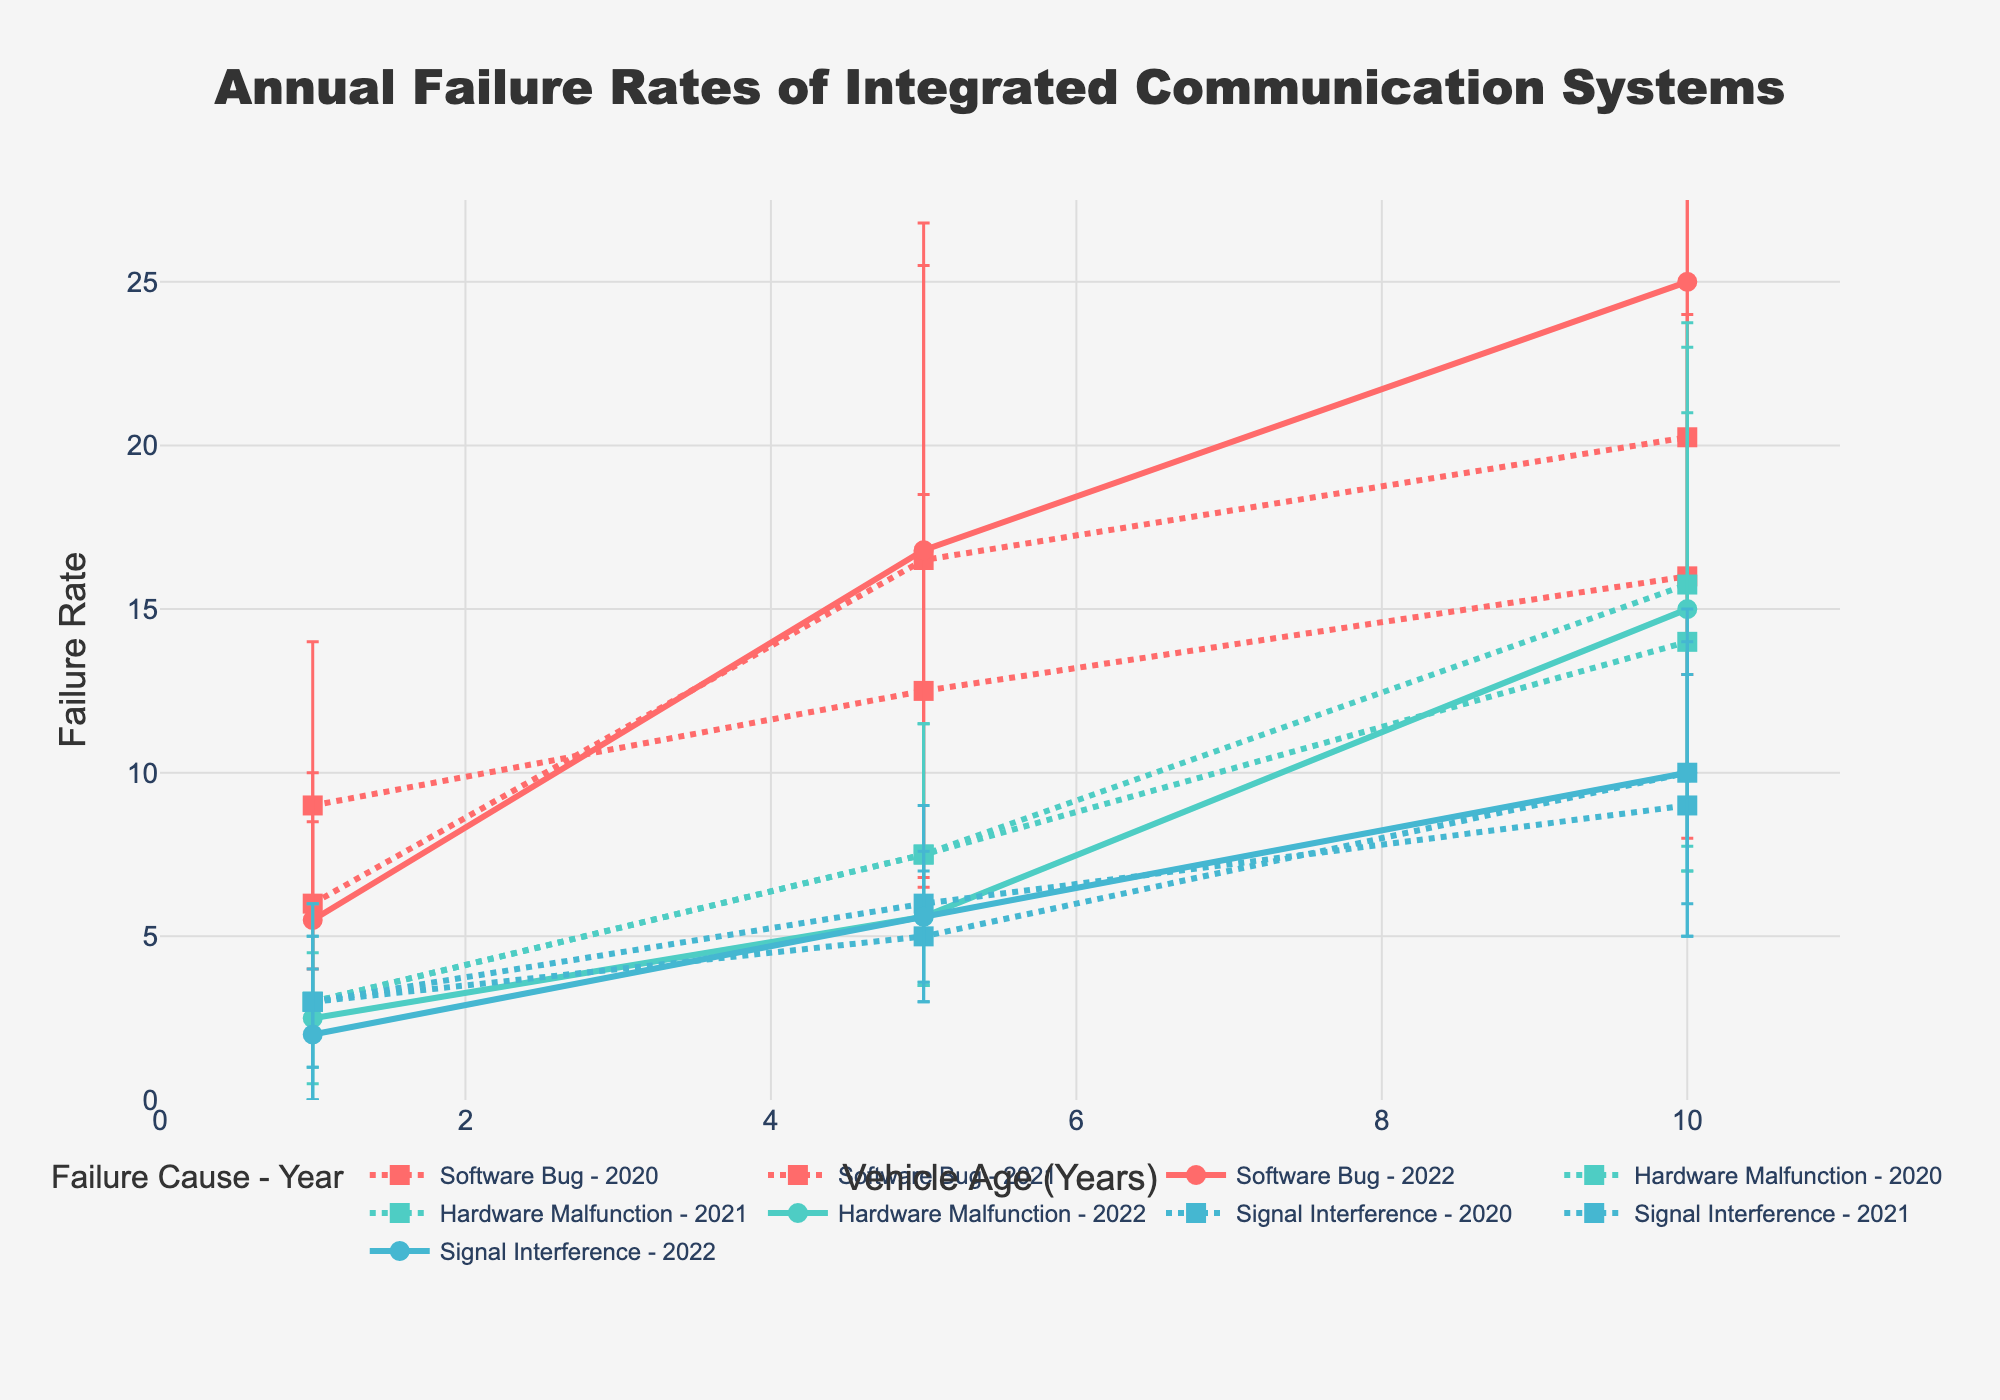What's the title of the figure? The title is displayed at the top of the figure and typically summarises what the figure represents. The title in this figure is "Annual Failure Rates of Integrated Communication Systems".
Answer: Annual Failure Rates of Integrated Communication Systems What are the x-axis and y-axis titles? The titles of the axes are given in the figure to indicate what each axis represents. The x-axis title is "Vehicle Age (Years)" and the y-axis title is "Failure Rate".
Answer: Vehicle Age (Years); Failure Rate What is the color used for the "Hardware Malfunction" cause line plots? The color for each failure cause is consistent across the figure. In this figure, "Hardware Malfunction" is plotted in green.
Answer: Green Which failure cause and year has the highest failure rate for vehicles aged 10 years? To determine the highest failure rate, look at the y-axis value for each cause and year at the x-axis value of 10 years. In the plot for vehicles aged 10 years, "Software Bug" in 2022 has the highest failure rate.
Answer: Software Bug - 2022 What is the overall trend in failure rates for "Software Bug" from vehicle age 1 to 10 years? Analyze the line for "Software Bug" across different vehicle ages. The failure rate for "Software Bug" increases as vehicle age increases from 1 to 10 years.
Answer: Increasing Compare the error rates for "Signal Interference" in 2020 and 2021 for vehicles aged 5 years. Which year has a higher error rate and by how much? Look at the error bars for "Signal Interference" in 2020 and 2021 at vehicle age 5 years. The error rate in 2020 is 2, and in 2021 it is 3, so 2021 has a higher error rate by 1.
Answer: 2021, by 1 What is the average failure rate for "Hardware Malfunction" for vehicles aged 1 year across the three years? Calculate the failure rates for "Hardware Malfunction" in 2020, 2021, and 2022 for vehicles aged 1 year and find the average. The failure rates are 3, 3, and 2, so the average failure rate is (3+3+2)/3 = 2.67.
Answer: 2.67 Which failure cause shows the smallest variation in failure rate with increasing vehicle age? Examine the slopes and variations of each failure cause line with age. "Signal Interference" shows the smallest variation in failure rate with increasing vehicle age, as the lines are relatively flat.
Answer: Signal Interference Are the error rates for "Software Bug" generally increasing, decreasing, or stable over the years for vehicles aged 10 years? Look at the error bars for "Software Bug" over the years specifically for vehicles aged 10 years. The error rates are increasing from 8 (2020) to 10 (2021) to 12 (2022).
Answer: Increasing 